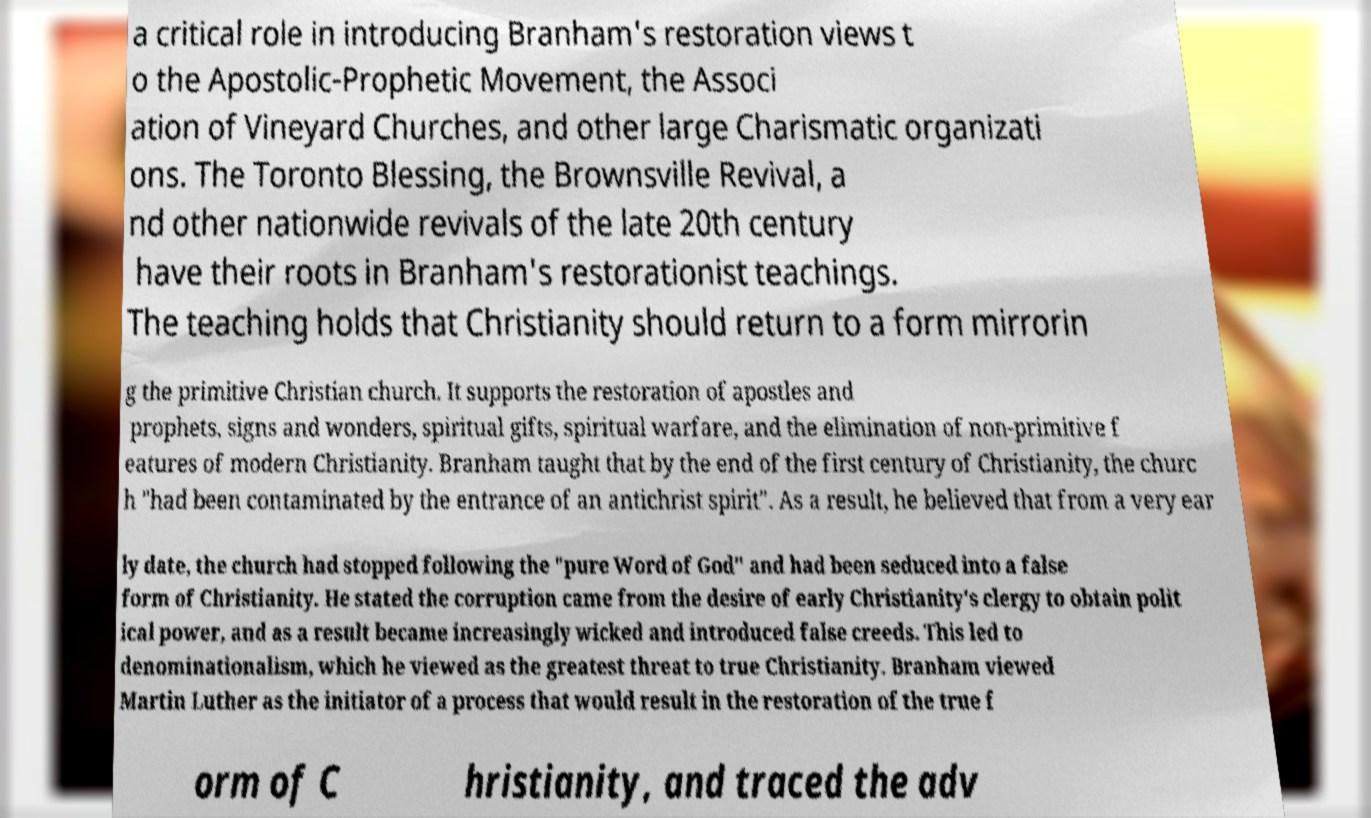I need the written content from this picture converted into text. Can you do that? a critical role in introducing Branham's restoration views t o the Apostolic-Prophetic Movement, the Associ ation of Vineyard Churches, and other large Charismatic organizati ons. The Toronto Blessing, the Brownsville Revival, a nd other nationwide revivals of the late 20th century have their roots in Branham's restorationist teachings. The teaching holds that Christianity should return to a form mirrorin g the primitive Christian church. It supports the restoration of apostles and prophets, signs and wonders, spiritual gifts, spiritual warfare, and the elimination of non-primitive f eatures of modern Christianity. Branham taught that by the end of the first century of Christianity, the churc h "had been contaminated by the entrance of an antichrist spirit". As a result, he believed that from a very ear ly date, the church had stopped following the "pure Word of God" and had been seduced into a false form of Christianity. He stated the corruption came from the desire of early Christianity's clergy to obtain polit ical power, and as a result became increasingly wicked and introduced false creeds. This led to denominationalism, which he viewed as the greatest threat to true Christianity. Branham viewed Martin Luther as the initiator of a process that would result in the restoration of the true f orm of C hristianity, and traced the adv 